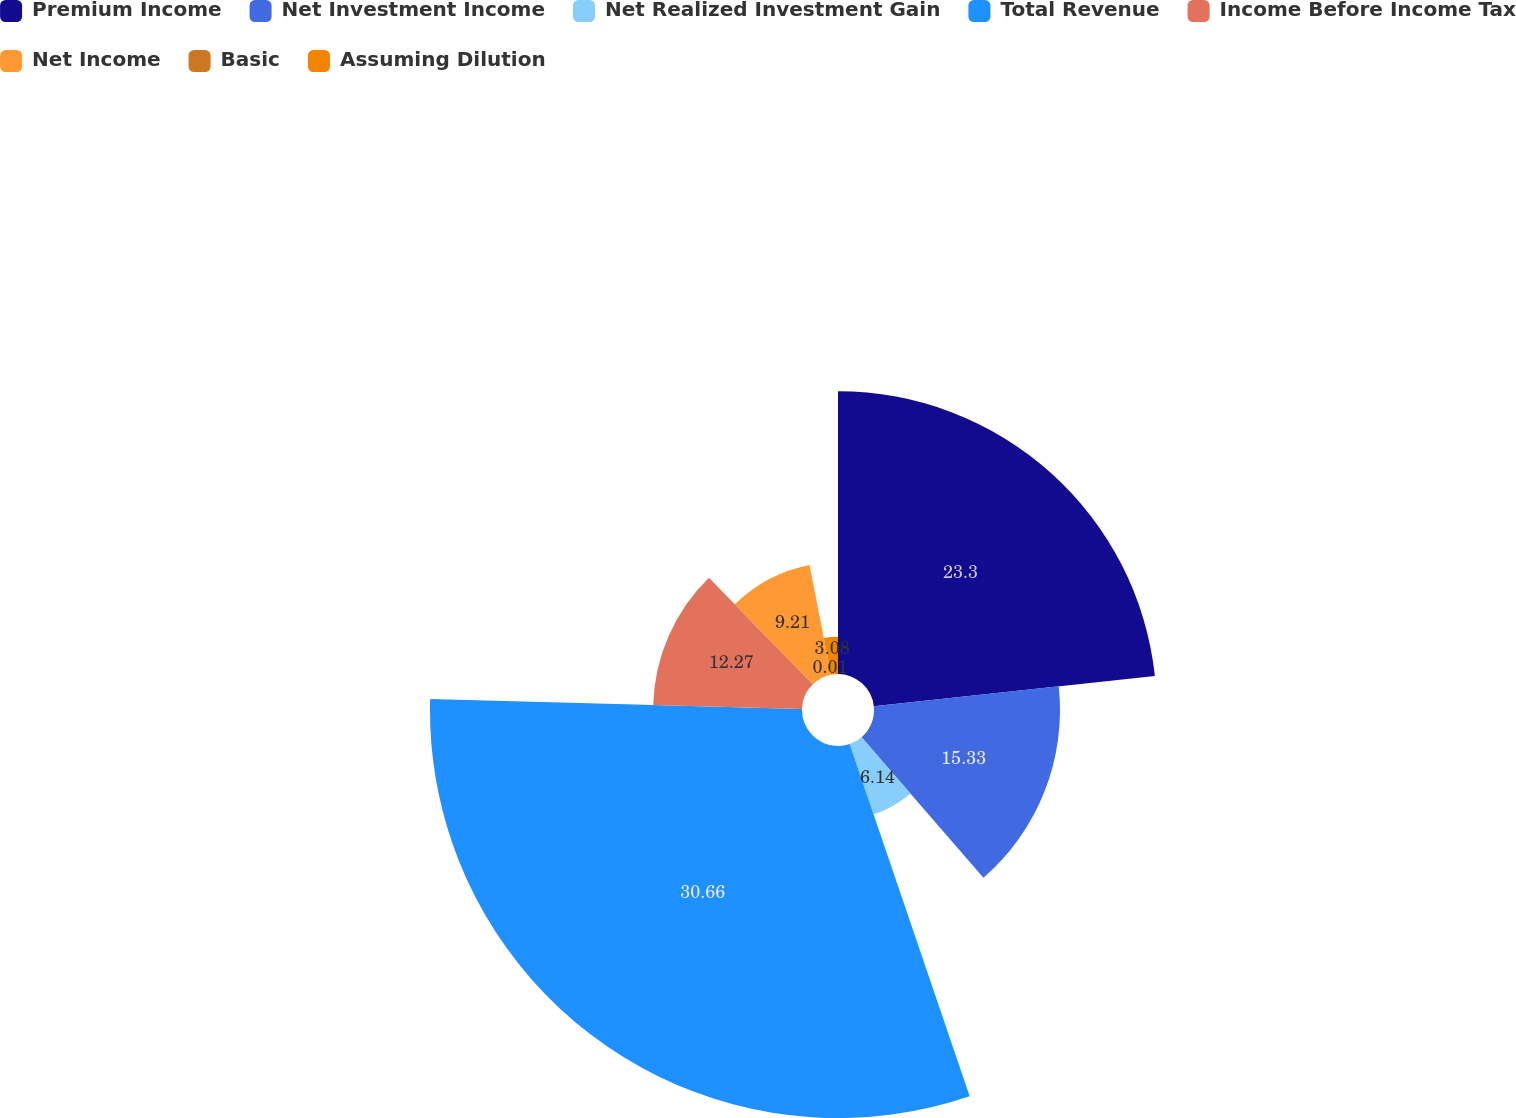Convert chart to OTSL. <chart><loc_0><loc_0><loc_500><loc_500><pie_chart><fcel>Premium Income<fcel>Net Investment Income<fcel>Net Realized Investment Gain<fcel>Total Revenue<fcel>Income Before Income Tax<fcel>Net Income<fcel>Basic<fcel>Assuming Dilution<nl><fcel>23.3%<fcel>15.33%<fcel>6.14%<fcel>30.66%<fcel>12.27%<fcel>9.21%<fcel>0.01%<fcel>3.08%<nl></chart> 